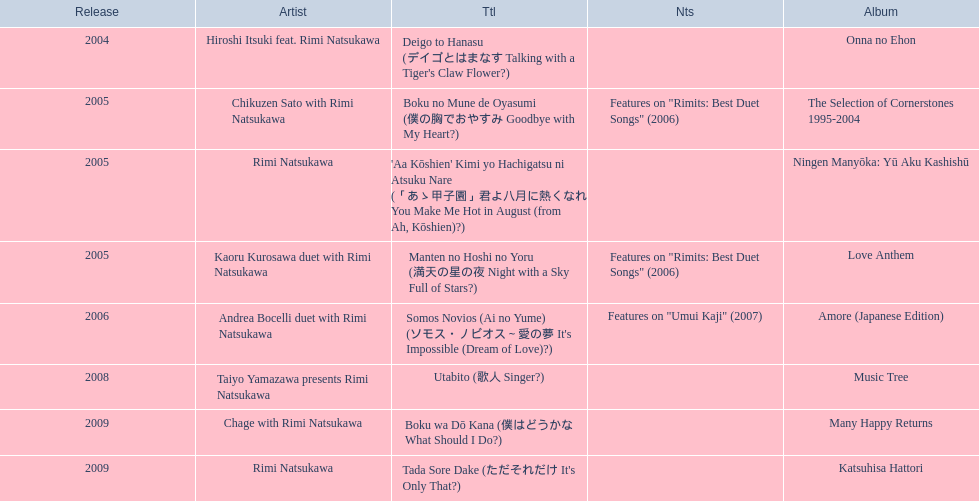What are the notes for sky full of stars? Features on "Rimits: Best Duet Songs" (2006). What other song features this same note? Boku no Mune de Oyasumi (僕の胸でおやすみ Goodbye with My Heart?). 